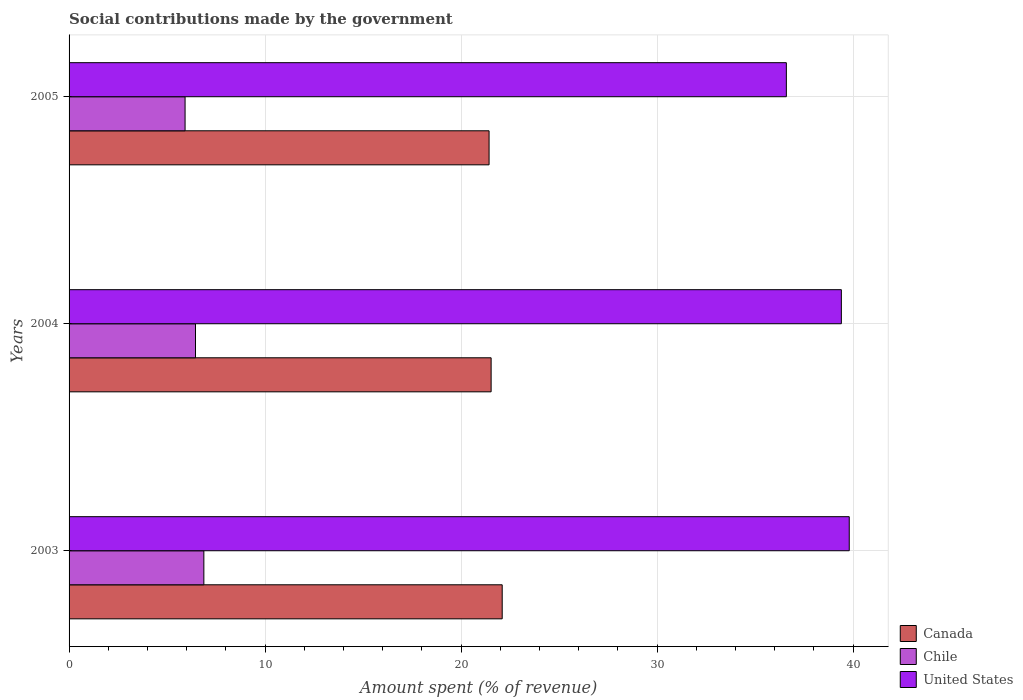How many groups of bars are there?
Keep it short and to the point. 3. How many bars are there on the 1st tick from the top?
Offer a terse response. 3. What is the label of the 1st group of bars from the top?
Give a very brief answer. 2005. In how many cases, is the number of bars for a given year not equal to the number of legend labels?
Provide a short and direct response. 0. What is the amount spent (in %) on social contributions in Chile in 2004?
Offer a terse response. 6.45. Across all years, what is the maximum amount spent (in %) on social contributions in Chile?
Provide a succinct answer. 6.88. Across all years, what is the minimum amount spent (in %) on social contributions in United States?
Your answer should be compact. 36.59. In which year was the amount spent (in %) on social contributions in United States maximum?
Ensure brevity in your answer.  2003. What is the total amount spent (in %) on social contributions in United States in the graph?
Ensure brevity in your answer.  115.79. What is the difference between the amount spent (in %) on social contributions in Canada in 2003 and that in 2004?
Your answer should be very brief. 0.56. What is the difference between the amount spent (in %) on social contributions in Chile in 2004 and the amount spent (in %) on social contributions in United States in 2003?
Your response must be concise. -33.35. What is the average amount spent (in %) on social contributions in Canada per year?
Keep it short and to the point. 21.69. In the year 2003, what is the difference between the amount spent (in %) on social contributions in Canada and amount spent (in %) on social contributions in Chile?
Offer a very short reply. 15.22. What is the ratio of the amount spent (in %) on social contributions in Chile in 2003 to that in 2005?
Make the answer very short. 1.16. Is the difference between the amount spent (in %) on social contributions in Canada in 2004 and 2005 greater than the difference between the amount spent (in %) on social contributions in Chile in 2004 and 2005?
Your response must be concise. No. What is the difference between the highest and the second highest amount spent (in %) on social contributions in Chile?
Your response must be concise. 0.43. What is the difference between the highest and the lowest amount spent (in %) on social contributions in Chile?
Ensure brevity in your answer.  0.96. In how many years, is the amount spent (in %) on social contributions in United States greater than the average amount spent (in %) on social contributions in United States taken over all years?
Provide a short and direct response. 2. What does the 1st bar from the bottom in 2004 represents?
Keep it short and to the point. Canada. Is it the case that in every year, the sum of the amount spent (in %) on social contributions in United States and amount spent (in %) on social contributions in Canada is greater than the amount spent (in %) on social contributions in Chile?
Make the answer very short. Yes. How many bars are there?
Ensure brevity in your answer.  9. How many years are there in the graph?
Your answer should be very brief. 3. Are the values on the major ticks of X-axis written in scientific E-notation?
Keep it short and to the point. No. Does the graph contain any zero values?
Offer a terse response. No. Does the graph contain grids?
Give a very brief answer. Yes. How are the legend labels stacked?
Your response must be concise. Vertical. What is the title of the graph?
Make the answer very short. Social contributions made by the government. What is the label or title of the X-axis?
Make the answer very short. Amount spent (% of revenue). What is the label or title of the Y-axis?
Your answer should be very brief. Years. What is the Amount spent (% of revenue) of Canada in 2003?
Ensure brevity in your answer.  22.1. What is the Amount spent (% of revenue) of Chile in 2003?
Keep it short and to the point. 6.88. What is the Amount spent (% of revenue) of United States in 2003?
Provide a succinct answer. 39.8. What is the Amount spent (% of revenue) of Canada in 2004?
Your answer should be compact. 21.53. What is the Amount spent (% of revenue) in Chile in 2004?
Provide a succinct answer. 6.45. What is the Amount spent (% of revenue) in United States in 2004?
Provide a succinct answer. 39.4. What is the Amount spent (% of revenue) of Canada in 2005?
Your response must be concise. 21.43. What is the Amount spent (% of revenue) in Chile in 2005?
Your answer should be very brief. 5.92. What is the Amount spent (% of revenue) of United States in 2005?
Give a very brief answer. 36.59. Across all years, what is the maximum Amount spent (% of revenue) of Canada?
Ensure brevity in your answer.  22.1. Across all years, what is the maximum Amount spent (% of revenue) in Chile?
Ensure brevity in your answer.  6.88. Across all years, what is the maximum Amount spent (% of revenue) of United States?
Give a very brief answer. 39.8. Across all years, what is the minimum Amount spent (% of revenue) in Canada?
Provide a short and direct response. 21.43. Across all years, what is the minimum Amount spent (% of revenue) in Chile?
Offer a terse response. 5.92. Across all years, what is the minimum Amount spent (% of revenue) in United States?
Give a very brief answer. 36.59. What is the total Amount spent (% of revenue) of Canada in the graph?
Keep it short and to the point. 65.06. What is the total Amount spent (% of revenue) of Chile in the graph?
Ensure brevity in your answer.  19.24. What is the total Amount spent (% of revenue) in United States in the graph?
Offer a very short reply. 115.79. What is the difference between the Amount spent (% of revenue) of Canada in 2003 and that in 2004?
Ensure brevity in your answer.  0.56. What is the difference between the Amount spent (% of revenue) of Chile in 2003 and that in 2004?
Keep it short and to the point. 0.43. What is the difference between the Amount spent (% of revenue) of United States in 2003 and that in 2004?
Keep it short and to the point. 0.4. What is the difference between the Amount spent (% of revenue) in Canada in 2003 and that in 2005?
Offer a terse response. 0.67. What is the difference between the Amount spent (% of revenue) of Chile in 2003 and that in 2005?
Ensure brevity in your answer.  0.96. What is the difference between the Amount spent (% of revenue) of United States in 2003 and that in 2005?
Provide a succinct answer. 3.21. What is the difference between the Amount spent (% of revenue) in Canada in 2004 and that in 2005?
Your response must be concise. 0.1. What is the difference between the Amount spent (% of revenue) of Chile in 2004 and that in 2005?
Your answer should be very brief. 0.53. What is the difference between the Amount spent (% of revenue) in United States in 2004 and that in 2005?
Your answer should be compact. 2.81. What is the difference between the Amount spent (% of revenue) in Canada in 2003 and the Amount spent (% of revenue) in Chile in 2004?
Provide a succinct answer. 15.65. What is the difference between the Amount spent (% of revenue) in Canada in 2003 and the Amount spent (% of revenue) in United States in 2004?
Offer a terse response. -17.3. What is the difference between the Amount spent (% of revenue) of Chile in 2003 and the Amount spent (% of revenue) of United States in 2004?
Offer a very short reply. -32.52. What is the difference between the Amount spent (% of revenue) of Canada in 2003 and the Amount spent (% of revenue) of Chile in 2005?
Your answer should be compact. 16.18. What is the difference between the Amount spent (% of revenue) in Canada in 2003 and the Amount spent (% of revenue) in United States in 2005?
Your answer should be very brief. -14.5. What is the difference between the Amount spent (% of revenue) in Chile in 2003 and the Amount spent (% of revenue) in United States in 2005?
Make the answer very short. -29.72. What is the difference between the Amount spent (% of revenue) of Canada in 2004 and the Amount spent (% of revenue) of Chile in 2005?
Your answer should be very brief. 15.61. What is the difference between the Amount spent (% of revenue) of Canada in 2004 and the Amount spent (% of revenue) of United States in 2005?
Your response must be concise. -15.06. What is the difference between the Amount spent (% of revenue) of Chile in 2004 and the Amount spent (% of revenue) of United States in 2005?
Keep it short and to the point. -30.14. What is the average Amount spent (% of revenue) of Canada per year?
Provide a succinct answer. 21.69. What is the average Amount spent (% of revenue) in Chile per year?
Your response must be concise. 6.41. What is the average Amount spent (% of revenue) of United States per year?
Your answer should be very brief. 38.6. In the year 2003, what is the difference between the Amount spent (% of revenue) of Canada and Amount spent (% of revenue) of Chile?
Provide a short and direct response. 15.22. In the year 2003, what is the difference between the Amount spent (% of revenue) of Canada and Amount spent (% of revenue) of United States?
Your answer should be very brief. -17.71. In the year 2003, what is the difference between the Amount spent (% of revenue) of Chile and Amount spent (% of revenue) of United States?
Your response must be concise. -32.93. In the year 2004, what is the difference between the Amount spent (% of revenue) in Canada and Amount spent (% of revenue) in Chile?
Provide a short and direct response. 15.08. In the year 2004, what is the difference between the Amount spent (% of revenue) in Canada and Amount spent (% of revenue) in United States?
Make the answer very short. -17.87. In the year 2004, what is the difference between the Amount spent (% of revenue) of Chile and Amount spent (% of revenue) of United States?
Keep it short and to the point. -32.95. In the year 2005, what is the difference between the Amount spent (% of revenue) of Canada and Amount spent (% of revenue) of Chile?
Provide a short and direct response. 15.51. In the year 2005, what is the difference between the Amount spent (% of revenue) in Canada and Amount spent (% of revenue) in United States?
Your answer should be compact. -15.17. In the year 2005, what is the difference between the Amount spent (% of revenue) in Chile and Amount spent (% of revenue) in United States?
Your answer should be very brief. -30.67. What is the ratio of the Amount spent (% of revenue) of Canada in 2003 to that in 2004?
Provide a short and direct response. 1.03. What is the ratio of the Amount spent (% of revenue) of Chile in 2003 to that in 2004?
Provide a succinct answer. 1.07. What is the ratio of the Amount spent (% of revenue) in United States in 2003 to that in 2004?
Your response must be concise. 1.01. What is the ratio of the Amount spent (% of revenue) of Canada in 2003 to that in 2005?
Your answer should be compact. 1.03. What is the ratio of the Amount spent (% of revenue) of Chile in 2003 to that in 2005?
Give a very brief answer. 1.16. What is the ratio of the Amount spent (% of revenue) of United States in 2003 to that in 2005?
Offer a terse response. 1.09. What is the ratio of the Amount spent (% of revenue) of Canada in 2004 to that in 2005?
Give a very brief answer. 1. What is the ratio of the Amount spent (% of revenue) of Chile in 2004 to that in 2005?
Offer a very short reply. 1.09. What is the ratio of the Amount spent (% of revenue) of United States in 2004 to that in 2005?
Ensure brevity in your answer.  1.08. What is the difference between the highest and the second highest Amount spent (% of revenue) of Canada?
Offer a very short reply. 0.56. What is the difference between the highest and the second highest Amount spent (% of revenue) of Chile?
Offer a very short reply. 0.43. What is the difference between the highest and the second highest Amount spent (% of revenue) in United States?
Provide a short and direct response. 0.4. What is the difference between the highest and the lowest Amount spent (% of revenue) in Canada?
Your answer should be compact. 0.67. What is the difference between the highest and the lowest Amount spent (% of revenue) in Chile?
Provide a short and direct response. 0.96. What is the difference between the highest and the lowest Amount spent (% of revenue) of United States?
Your response must be concise. 3.21. 